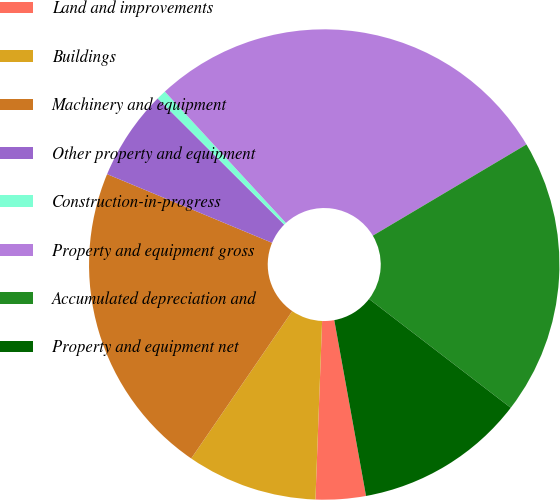Convert chart to OTSL. <chart><loc_0><loc_0><loc_500><loc_500><pie_chart><fcel>Land and improvements<fcel>Buildings<fcel>Machinery and equipment<fcel>Other property and equipment<fcel>Construction-in-progress<fcel>Property and equipment gross<fcel>Accumulated depreciation and<fcel>Property and equipment net<nl><fcel>3.44%<fcel>8.97%<fcel>21.71%<fcel>6.2%<fcel>0.67%<fcel>28.32%<fcel>18.95%<fcel>11.73%<nl></chart> 